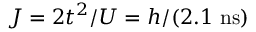Convert formula to latex. <formula><loc_0><loc_0><loc_500><loc_500>J = 2 t ^ { 2 } / U = h / ( 2 . 1 n s )</formula> 